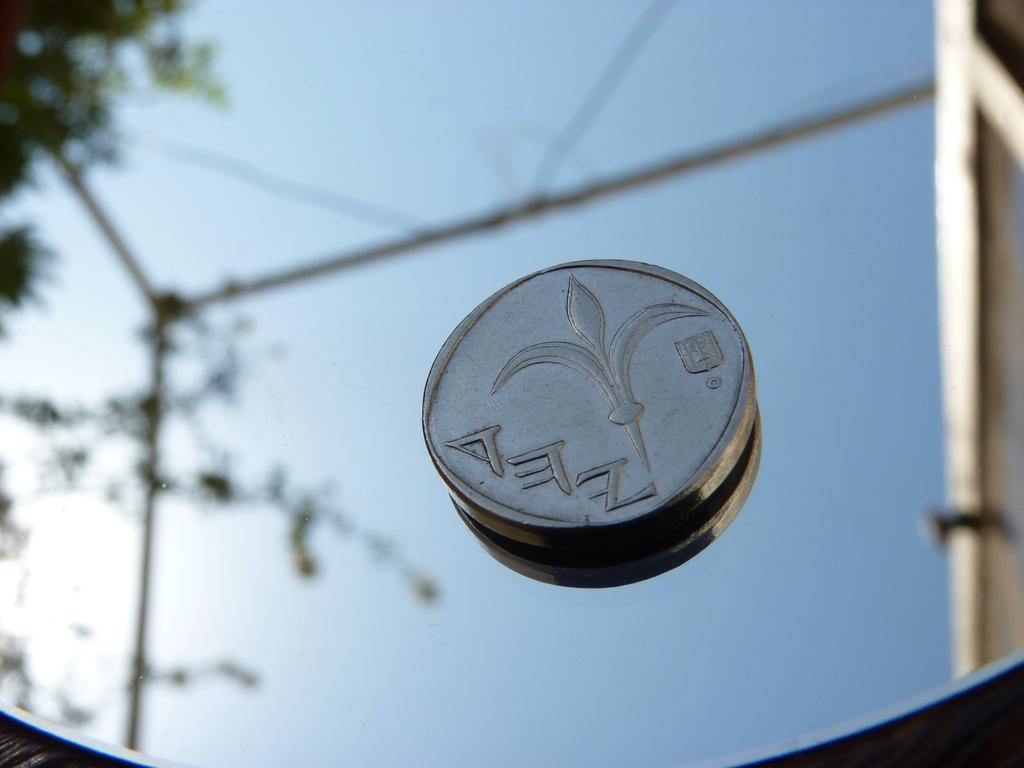What object is placed on the mirror in the image? There is a coin on the mirror in the image. What can be seen in the mirror besides the coin? The sky and a tree are reflected in the mirror, as well as poles. What is the primary purpose of the mirror in the image? The mirror is reflecting the surrounding environment, including the sky, tree, and poles. What type of army is marching in the image? There is no army present in the image; it only features a coin on a mirror and reflections of the sky, tree, and poles. 